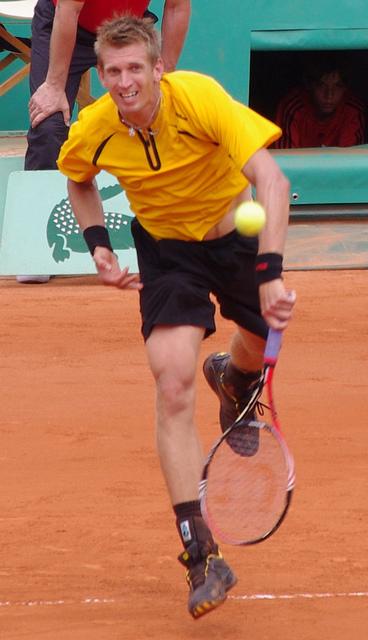What color are his shoes?
Keep it brief. Black. What color is this shirt?
Write a very short answer. Yellow. Are both feet on the ground?
Write a very short answer. No. Is the man wearing white shorts?
Write a very short answer. No. What is the man holding?
Give a very brief answer. Tennis racket. What color is the tennis ball?
Short answer required. Yellow. What color are his socks?
Keep it brief. Black. Is this player right handed or left handed?
Write a very short answer. Left. What sport is he playing?
Give a very brief answer. Tennis. How many people are there?
Short answer required. 2. Are his socks the same brand as his shoes?
Concise answer only. No. What color socks are they?
Give a very brief answer. Black. What kind of floor is in the picture?
Be succinct. Clay. 